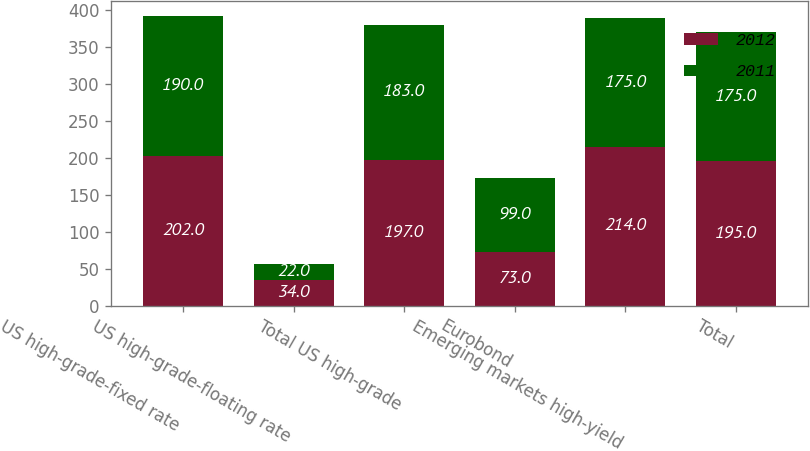Convert chart. <chart><loc_0><loc_0><loc_500><loc_500><stacked_bar_chart><ecel><fcel>US high-grade-fixed rate<fcel>US high-grade-floating rate<fcel>Total US high-grade<fcel>Eurobond<fcel>Emerging markets high-yield<fcel>Total<nl><fcel>2012<fcel>202<fcel>34<fcel>197<fcel>73<fcel>214<fcel>195<nl><fcel>2011<fcel>190<fcel>22<fcel>183<fcel>99<fcel>175<fcel>175<nl></chart> 